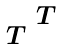Convert formula to latex. <formula><loc_0><loc_0><loc_500><loc_500>\begin{smallmatrix} & T \\ T & \\ \end{smallmatrix}</formula> 